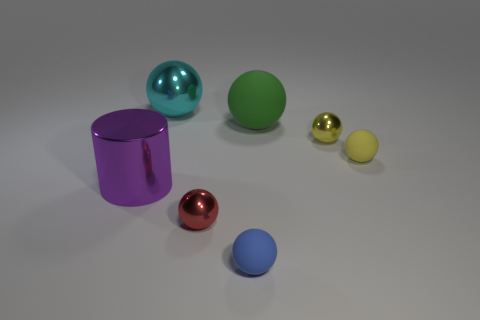Add 1 large purple objects. How many objects exist? 8 Subtract all small balls. How many balls are left? 2 Subtract all purple cylinders. How many yellow spheres are left? 2 Subtract all red balls. How many balls are left? 5 Subtract all balls. How many objects are left? 1 Subtract all green balls. Subtract all red cylinders. How many balls are left? 5 Subtract all yellow shiny blocks. Subtract all tiny blue balls. How many objects are left? 6 Add 7 tiny red balls. How many tiny red balls are left? 8 Add 2 tiny shiny spheres. How many tiny shiny spheres exist? 4 Subtract 0 purple spheres. How many objects are left? 7 